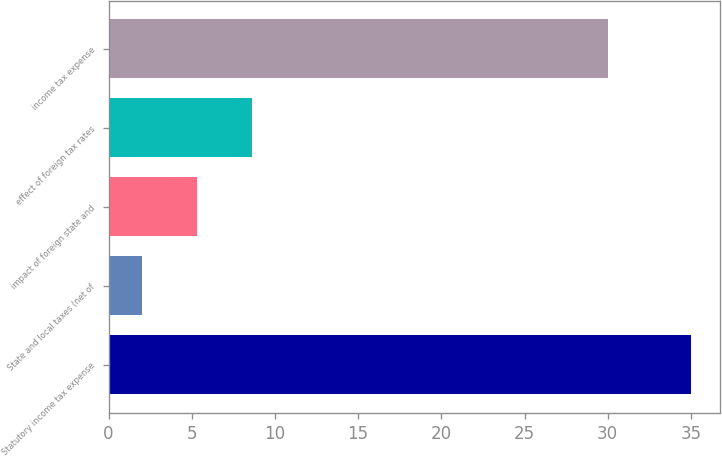<chart> <loc_0><loc_0><loc_500><loc_500><bar_chart><fcel>Statutory income tax expense<fcel>State and local taxes (net of<fcel>impact of foreign state and<fcel>effect of foreign tax rates<fcel>income tax expense<nl><fcel>35<fcel>2<fcel>5.3<fcel>8.6<fcel>30<nl></chart> 